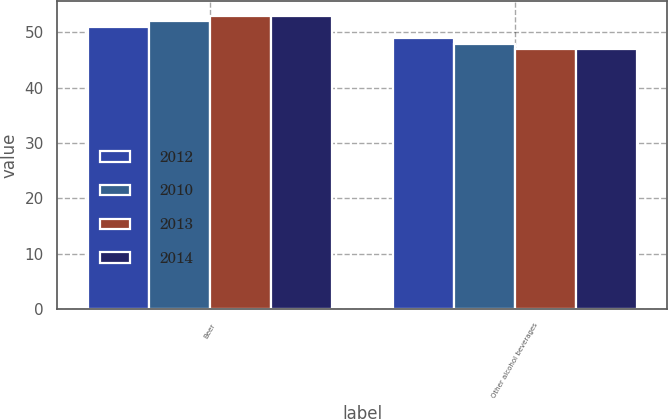<chart> <loc_0><loc_0><loc_500><loc_500><stacked_bar_chart><ecel><fcel>Beer<fcel>Other alcohol beverages<nl><fcel>2012<fcel>51<fcel>49<nl><fcel>2010<fcel>52<fcel>48<nl><fcel>2013<fcel>53<fcel>47<nl><fcel>2014<fcel>53<fcel>47<nl></chart> 